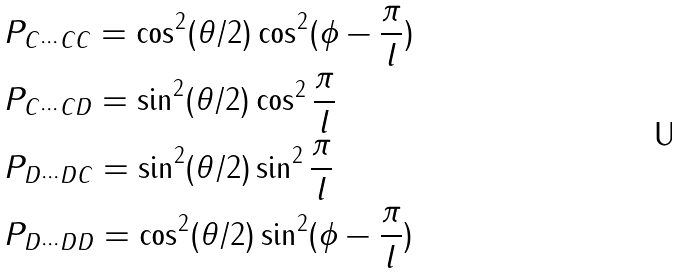Convert formula to latex. <formula><loc_0><loc_0><loc_500><loc_500>& P _ { C \cdots C C } = \cos ^ { 2 } ( \theta / 2 ) \cos ^ { 2 } ( \phi - \frac { \pi } { l } ) \\ & P _ { C \cdots C D } = \sin ^ { 2 } ( \theta / 2 ) \cos ^ { 2 } \frac { \pi } { l } \\ & P _ { D \cdots D C } = \sin ^ { 2 } ( \theta / 2 ) \sin ^ { 2 } \frac { \pi } { l } \\ & P _ { D \cdots D D } = \cos ^ { 2 } ( \theta / 2 ) \sin ^ { 2 } ( \phi - \frac { \pi } { l } )</formula> 